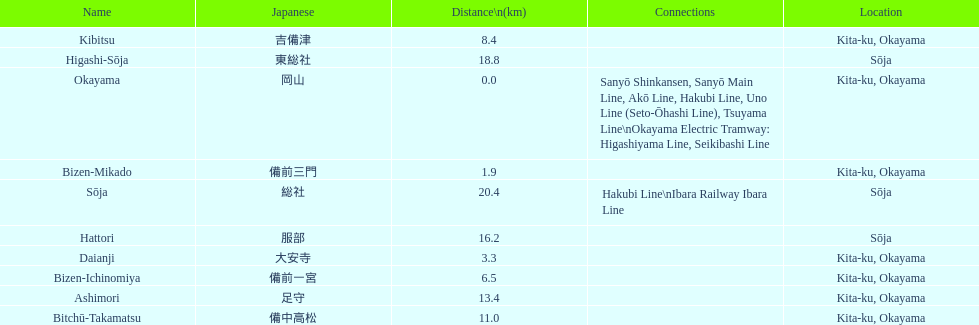Which has the most distance, hattori or kibitsu? Hattori. 